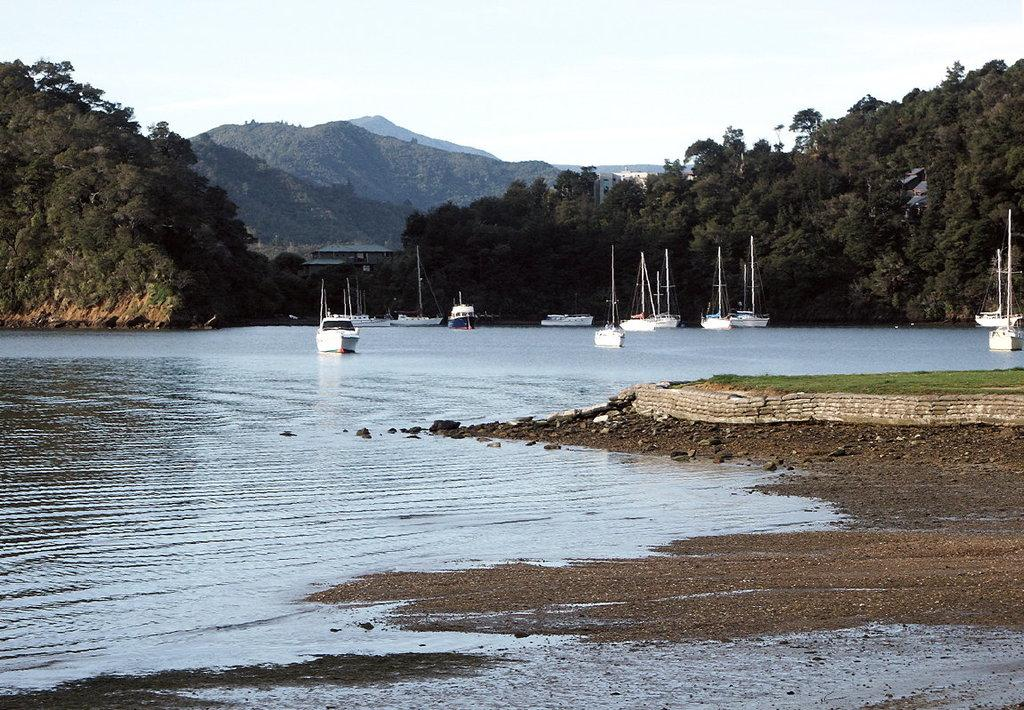What type of terrain is on the right side of the image? There is land on the right side of the image. What can be seen in the middle of the image? There are ships in the middle of the image. What is visible in the background of the image? The sky is visible in the background of the image. Where is the bomb located in the image? There is no bomb present in the image. What type of liquid can be seen flowing from the ships in the image? There is no liquid flowing from the ships in the image; only the ships themselves are visible. 